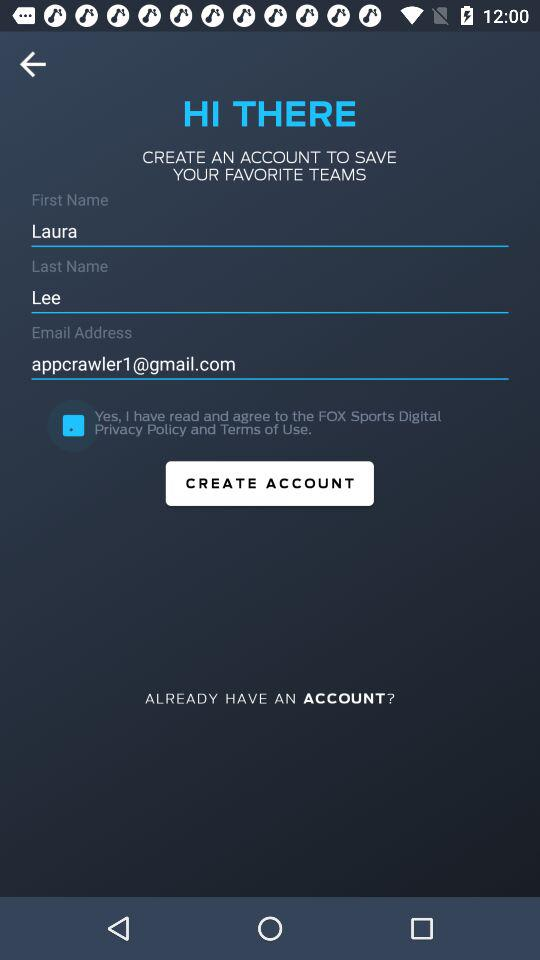What is the email address? The email address is appcrowler1@gmail.com. 